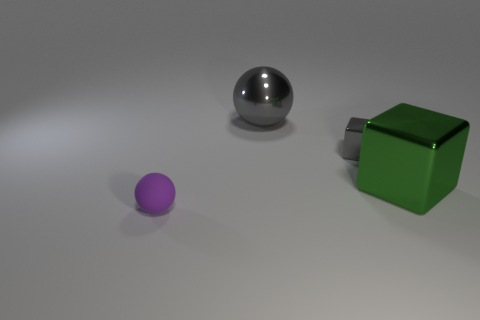What shape is the thing that is in front of the tiny metallic block and behind the purple ball?
Your answer should be compact. Cube. Is there any other thing that is the same material as the purple sphere?
Your response must be concise. No. There is a matte object; is it the same size as the metallic cube that is on the left side of the large green object?
Your answer should be compact. Yes. How many other objects are the same color as the small sphere?
Your answer should be compact. 0. There is a big gray metallic ball; are there any small purple things in front of it?
Make the answer very short. Yes. How many things are small gray metallic things or objects to the left of the small gray block?
Make the answer very short. 3. There is a small thing behind the tiny matte ball; is there a tiny cube that is left of it?
Make the answer very short. No. What is the shape of the gray thing right of the gray metal object that is behind the small object on the right side of the tiny purple matte thing?
Ensure brevity in your answer.  Cube. What is the color of the object that is both in front of the tiny gray cube and to the right of the purple thing?
Your answer should be very brief. Green. There is a big thing that is to the left of the small gray object; what shape is it?
Give a very brief answer. Sphere. 